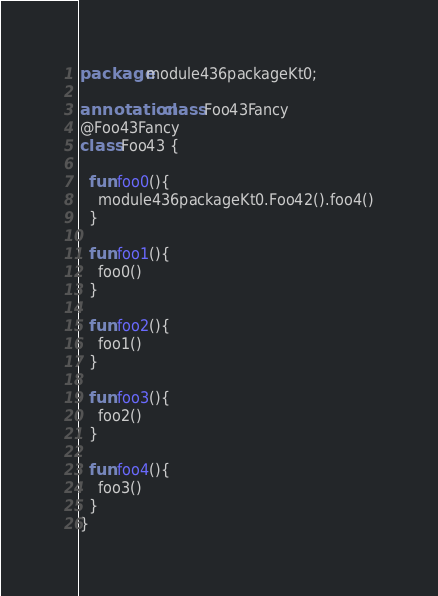Convert code to text. <code><loc_0><loc_0><loc_500><loc_500><_Kotlin_>package module436packageKt0;

annotation class Foo43Fancy
@Foo43Fancy
class Foo43 {

  fun foo0(){
    module436packageKt0.Foo42().foo4()
  }

  fun foo1(){
    foo0()
  }

  fun foo2(){
    foo1()
  }

  fun foo3(){
    foo2()
  }

  fun foo4(){
    foo3()
  }
}</code> 